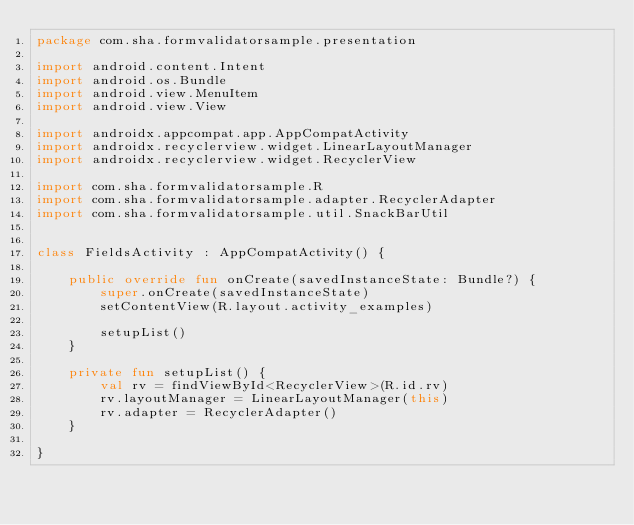Convert code to text. <code><loc_0><loc_0><loc_500><loc_500><_Kotlin_>package com.sha.formvalidatorsample.presentation

import android.content.Intent
import android.os.Bundle
import android.view.MenuItem
import android.view.View

import androidx.appcompat.app.AppCompatActivity
import androidx.recyclerview.widget.LinearLayoutManager
import androidx.recyclerview.widget.RecyclerView

import com.sha.formvalidatorsample.R
import com.sha.formvalidatorsample.adapter.RecyclerAdapter
import com.sha.formvalidatorsample.util.SnackBarUtil


class FieldsActivity : AppCompatActivity() {

    public override fun onCreate(savedInstanceState: Bundle?) {
        super.onCreate(savedInstanceState)
        setContentView(R.layout.activity_examples)

        setupList()
    }

    private fun setupList() {
        val rv = findViewById<RecyclerView>(R.id.rv)
        rv.layoutManager = LinearLayoutManager(this)
        rv.adapter = RecyclerAdapter()
    }

}</code> 